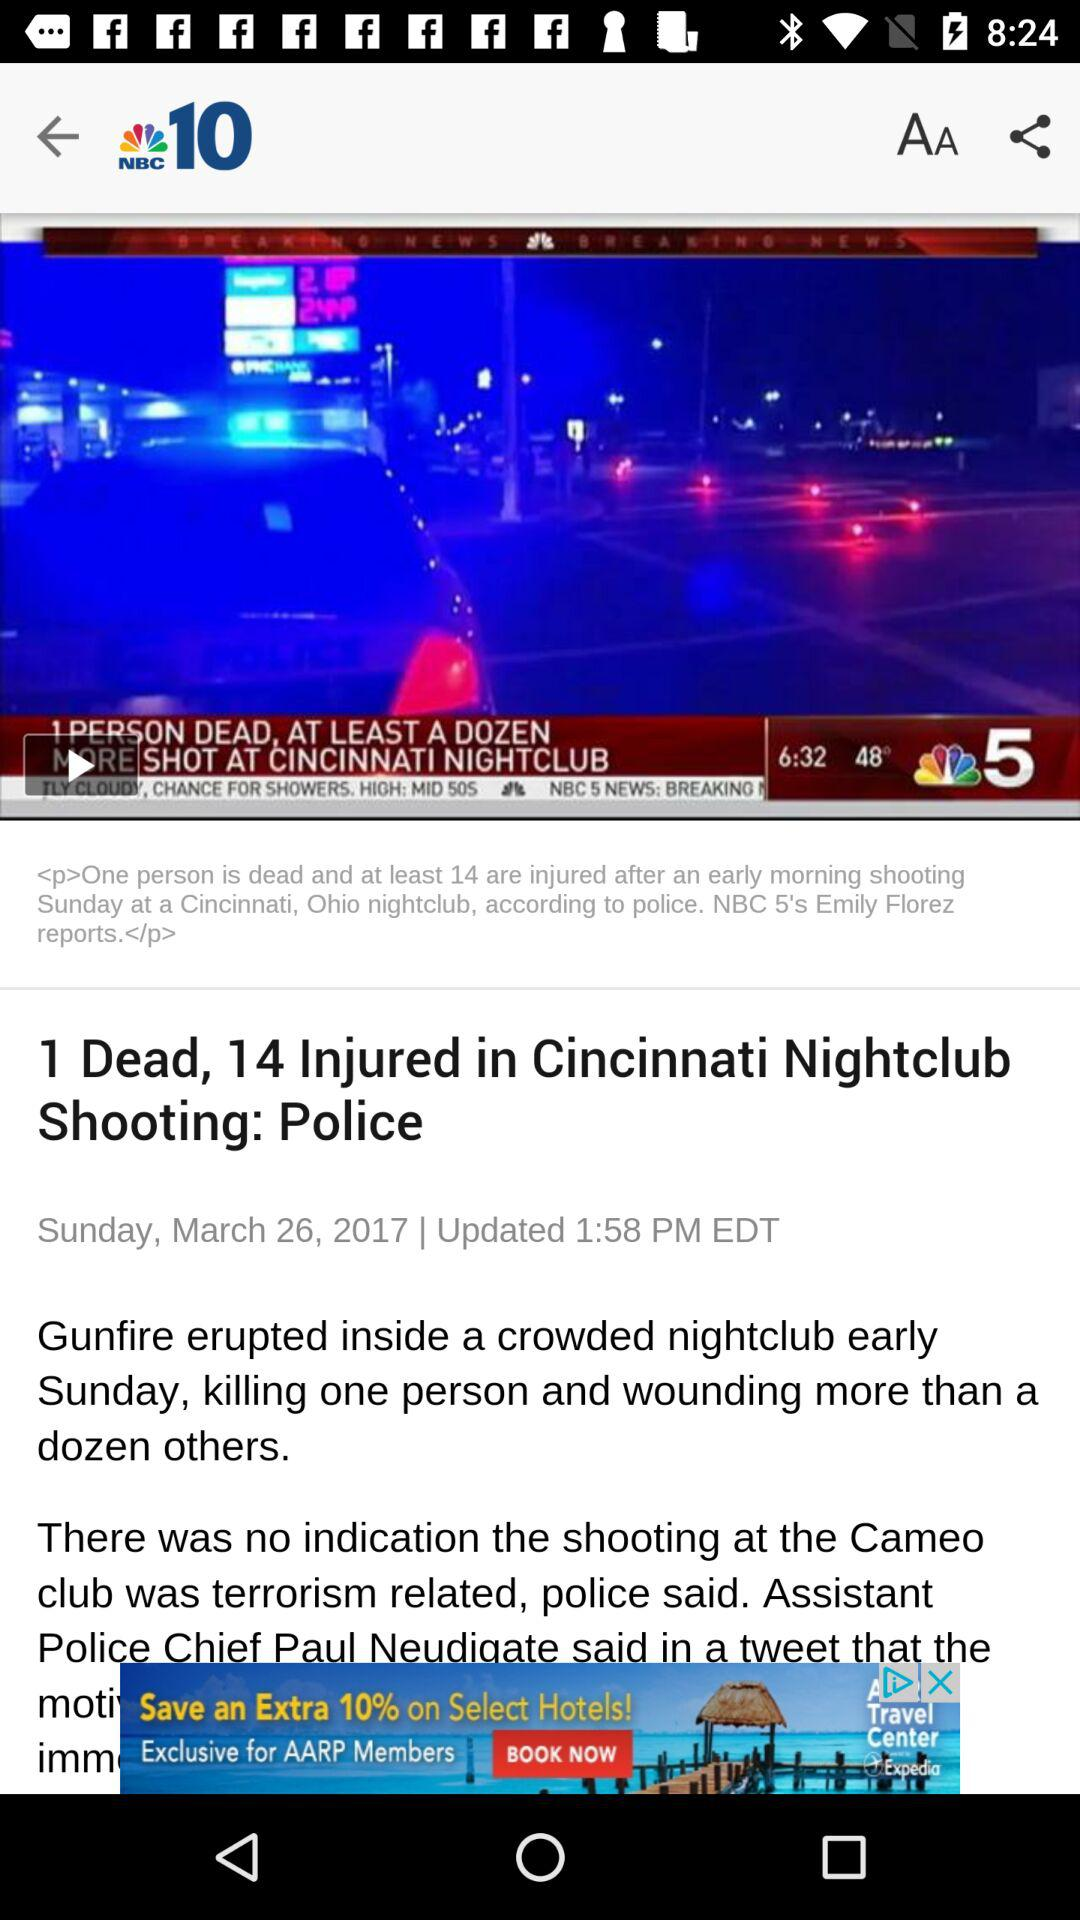How many more people were injured than killed in the Cincinnati nightclub shooting?
Answer the question using a single word or phrase. 13 